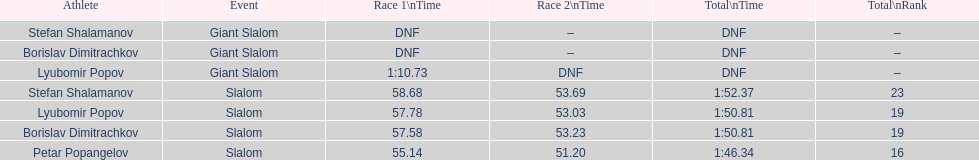Who has the highest rank? Petar Popangelov. 